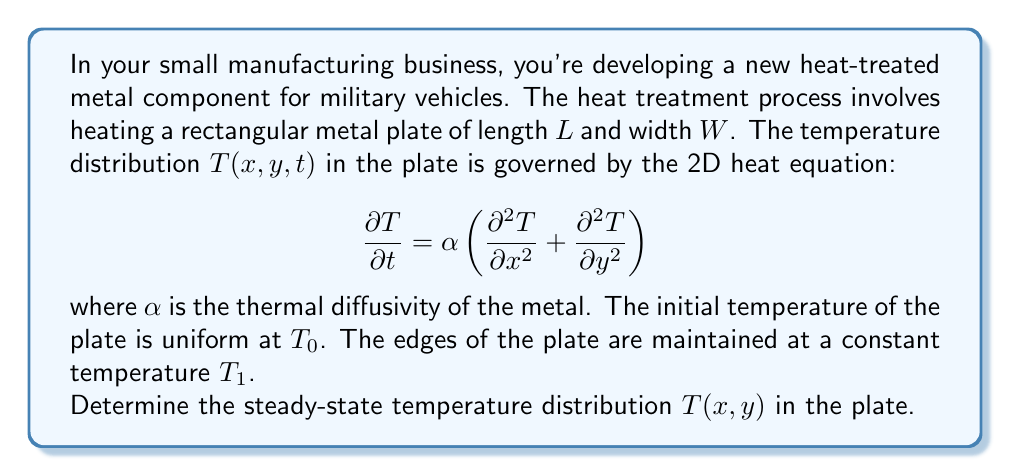Can you solve this math problem? To solve this problem, we'll follow these steps:

1) For the steady-state solution, the temperature doesn't change with time, so $\frac{\partial T}{\partial t} = 0$. This reduces our equation to:

   $$0 = \alpha \left(\frac{\partial^2 T}{\partial x^2} + \frac{\partial^2 T}{\partial y^2}\right)$$

   Or simply:

   $$\frac{\partial^2 T}{\partial x^2} + \frac{\partial^2 T}{\partial y^2} = 0$$

   This is Laplace's equation in two dimensions.

2) The boundary conditions are:
   
   $T(0,y) = T(L,y) = T(x,0) = T(x,W) = T_1$

3) We can solve this using separation of variables. Let $T(x,y) = X(x)Y(y)$. Substituting this into Laplace's equation:

   $$X''(x)Y(y) + X(x)Y''(y) = 0$$

   Dividing by $X(x)Y(y)$:

   $$\frac{X''(x)}{X(x)} + \frac{Y''(y)}{Y(y)} = 0$$

4) For this to be true for all $x$ and $y$, both terms must be constant. Let's say:

   $$\frac{X''(x)}{X(x)} = -k^2 \quad \text{and} \quad \frac{Y''(y)}{Y(y)} = k^2$$

5) This gives us two ordinary differential equations:

   $X''(x) + k^2X(x) = 0$ and $Y''(y) - k^2Y(y) = 0$

6) The general solutions are:

   $X(x) = A \sin(kx) + B \cos(kx)$
   $Y(y) = C \sinh(ky) + D \cosh(ky)$

7) Applying the boundary conditions:

   $T(0,y) = T_1$ implies $B = T_1$
   $T(L,y) = T_1$ implies $A \sin(kL) + T_1 \cos(kL) = T_1$, so $k = \frac{n\pi}{L}$ where $n$ is an integer
   $T(x,0) = T_1$ implies $D = T_1$
   $T(x,W) = T_1$ implies $C \sinh(\frac{n\pi W}{L}) + T_1 \cosh(\frac{n\pi W}{L}) = T_1$

8) The complete solution is a sum over all values of $n$:

   $$T(x,y) = T_1 + \sum_{n=1}^{\infty} A_n \sin(\frac{n\pi x}{L}) \left[\sinh(\frac{n\pi y}{L}) - \frac{\sinh(\frac{n\pi W}{L})}{\cosh(\frac{n\pi W}{L})} \cosh(\frac{n\pi y}{L})\right]$$

   where $A_n$ are constants determined by the initial condition.

9) As $t \to \infty$, all terms in the sum approach zero due to the negative exponential in time (which we omitted for brevity). Therefore, the steady-state solution is simply:

   $$T(x,y) = T_1$$
Answer: $T(x,y) = T_1$ 